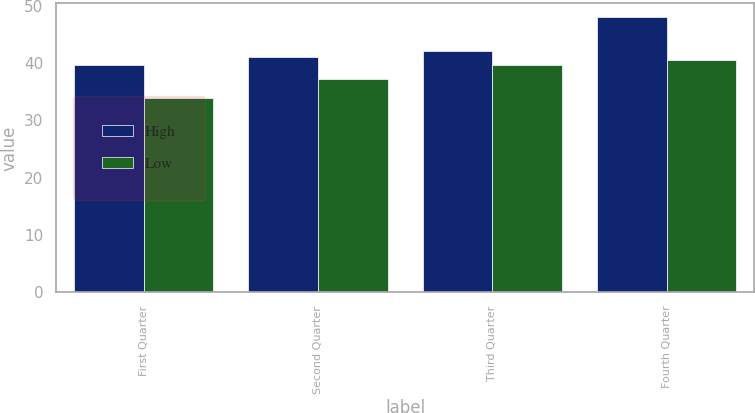<chart> <loc_0><loc_0><loc_500><loc_500><stacked_bar_chart><ecel><fcel>First Quarter<fcel>Second Quarter<fcel>Third Quarter<fcel>Fourth Quarter<nl><fcel>High<fcel>39.62<fcel>41.09<fcel>42.07<fcel>48.05<nl><fcel>Low<fcel>33.84<fcel>37.25<fcel>39.67<fcel>40.61<nl></chart> 